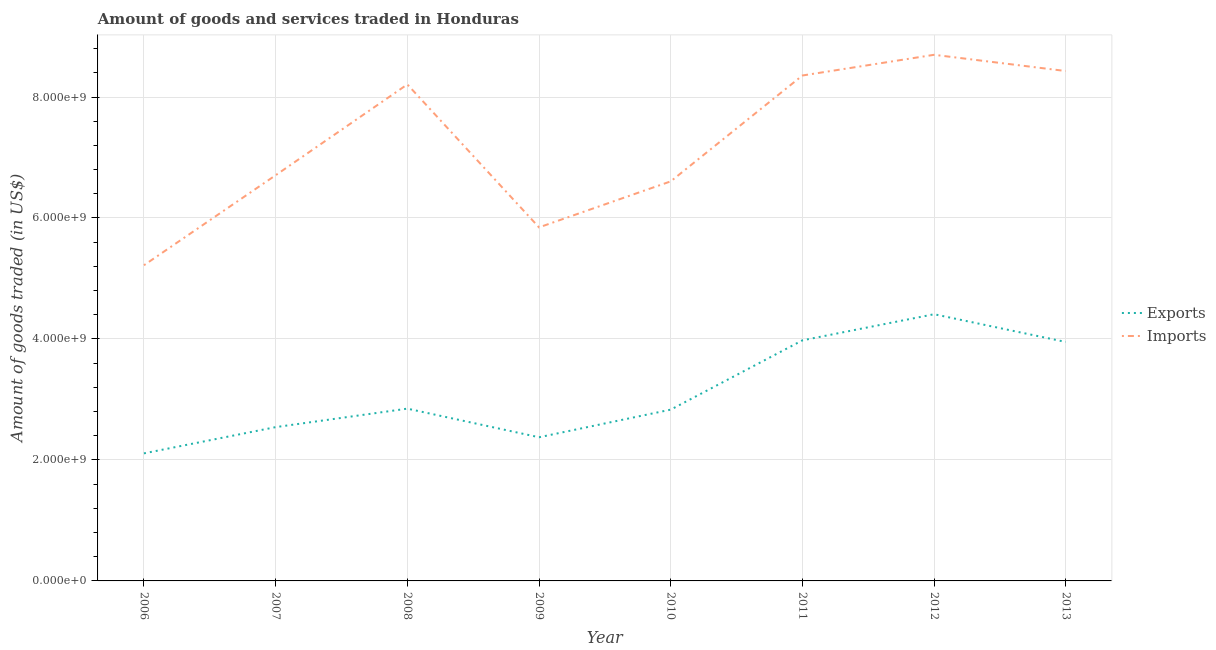Does the line corresponding to amount of goods exported intersect with the line corresponding to amount of goods imported?
Ensure brevity in your answer.  No. What is the amount of goods imported in 2007?
Ensure brevity in your answer.  6.71e+09. Across all years, what is the maximum amount of goods exported?
Your answer should be compact. 4.41e+09. Across all years, what is the minimum amount of goods imported?
Offer a very short reply. 5.22e+09. What is the total amount of goods imported in the graph?
Provide a short and direct response. 5.81e+1. What is the difference between the amount of goods exported in 2006 and that in 2007?
Your answer should be very brief. -4.34e+08. What is the difference between the amount of goods imported in 2011 and the amount of goods exported in 2008?
Offer a very short reply. 5.51e+09. What is the average amount of goods exported per year?
Your answer should be very brief. 3.13e+09. In the year 2008, what is the difference between the amount of goods imported and amount of goods exported?
Give a very brief answer. 5.36e+09. What is the ratio of the amount of goods imported in 2006 to that in 2012?
Provide a short and direct response. 0.6. Is the amount of goods exported in 2012 less than that in 2013?
Your response must be concise. No. Is the difference between the amount of goods imported in 2009 and 2010 greater than the difference between the amount of goods exported in 2009 and 2010?
Give a very brief answer. No. What is the difference between the highest and the second highest amount of goods imported?
Offer a very short reply. 2.68e+08. What is the difference between the highest and the lowest amount of goods exported?
Your answer should be compact. 2.30e+09. In how many years, is the amount of goods exported greater than the average amount of goods exported taken over all years?
Provide a short and direct response. 3. Is the sum of the amount of goods imported in 2008 and 2009 greater than the maximum amount of goods exported across all years?
Give a very brief answer. Yes. Is the amount of goods exported strictly greater than the amount of goods imported over the years?
Give a very brief answer. No. Is the amount of goods imported strictly less than the amount of goods exported over the years?
Your answer should be compact. No. How many lines are there?
Offer a terse response. 2. How many years are there in the graph?
Offer a terse response. 8. Does the graph contain grids?
Provide a succinct answer. Yes. How are the legend labels stacked?
Your response must be concise. Vertical. What is the title of the graph?
Offer a very short reply. Amount of goods and services traded in Honduras. Does "current US$" appear as one of the legend labels in the graph?
Make the answer very short. No. What is the label or title of the Y-axis?
Make the answer very short. Amount of goods traded (in US$). What is the Amount of goods traded (in US$) of Exports in 2006?
Ensure brevity in your answer.  2.11e+09. What is the Amount of goods traded (in US$) in Imports in 2006?
Provide a succinct answer. 5.22e+09. What is the Amount of goods traded (in US$) of Exports in 2007?
Keep it short and to the point. 2.54e+09. What is the Amount of goods traded (in US$) of Imports in 2007?
Your response must be concise. 6.71e+09. What is the Amount of goods traded (in US$) in Exports in 2008?
Offer a terse response. 2.85e+09. What is the Amount of goods traded (in US$) of Imports in 2008?
Provide a succinct answer. 8.21e+09. What is the Amount of goods traded (in US$) of Exports in 2009?
Ensure brevity in your answer.  2.38e+09. What is the Amount of goods traded (in US$) of Imports in 2009?
Your response must be concise. 5.85e+09. What is the Amount of goods traded (in US$) of Exports in 2010?
Your response must be concise. 2.83e+09. What is the Amount of goods traded (in US$) of Imports in 2010?
Make the answer very short. 6.61e+09. What is the Amount of goods traded (in US$) of Exports in 2011?
Your answer should be very brief. 3.98e+09. What is the Amount of goods traded (in US$) in Imports in 2011?
Your answer should be compact. 8.36e+09. What is the Amount of goods traded (in US$) in Exports in 2012?
Your answer should be very brief. 4.41e+09. What is the Amount of goods traded (in US$) of Imports in 2012?
Provide a short and direct response. 8.70e+09. What is the Amount of goods traded (in US$) of Exports in 2013?
Your answer should be compact. 3.95e+09. What is the Amount of goods traded (in US$) in Imports in 2013?
Provide a short and direct response. 8.43e+09. Across all years, what is the maximum Amount of goods traded (in US$) of Exports?
Your answer should be compact. 4.41e+09. Across all years, what is the maximum Amount of goods traded (in US$) of Imports?
Your response must be concise. 8.70e+09. Across all years, what is the minimum Amount of goods traded (in US$) of Exports?
Your response must be concise. 2.11e+09. Across all years, what is the minimum Amount of goods traded (in US$) of Imports?
Keep it short and to the point. 5.22e+09. What is the total Amount of goods traded (in US$) in Exports in the graph?
Provide a succinct answer. 2.50e+1. What is the total Amount of goods traded (in US$) in Imports in the graph?
Offer a terse response. 5.81e+1. What is the difference between the Amount of goods traded (in US$) of Exports in 2006 and that in 2007?
Your answer should be compact. -4.34e+08. What is the difference between the Amount of goods traded (in US$) in Imports in 2006 and that in 2007?
Keep it short and to the point. -1.49e+09. What is the difference between the Amount of goods traded (in US$) in Exports in 2006 and that in 2008?
Give a very brief answer. -7.39e+08. What is the difference between the Amount of goods traded (in US$) of Imports in 2006 and that in 2008?
Your answer should be compact. -2.99e+09. What is the difference between the Amount of goods traded (in US$) in Exports in 2006 and that in 2009?
Offer a very short reply. -2.66e+08. What is the difference between the Amount of goods traded (in US$) in Imports in 2006 and that in 2009?
Give a very brief answer. -6.26e+08. What is the difference between the Amount of goods traded (in US$) of Exports in 2006 and that in 2010?
Offer a very short reply. -7.23e+08. What is the difference between the Amount of goods traded (in US$) of Imports in 2006 and that in 2010?
Provide a short and direct response. -1.39e+09. What is the difference between the Amount of goods traded (in US$) of Exports in 2006 and that in 2011?
Keep it short and to the point. -1.87e+09. What is the difference between the Amount of goods traded (in US$) in Imports in 2006 and that in 2011?
Your response must be concise. -3.14e+09. What is the difference between the Amount of goods traded (in US$) of Exports in 2006 and that in 2012?
Provide a succinct answer. -2.30e+09. What is the difference between the Amount of goods traded (in US$) of Imports in 2006 and that in 2012?
Your answer should be very brief. -3.48e+09. What is the difference between the Amount of goods traded (in US$) in Exports in 2006 and that in 2013?
Your response must be concise. -1.84e+09. What is the difference between the Amount of goods traded (in US$) of Imports in 2006 and that in 2013?
Your response must be concise. -3.21e+09. What is the difference between the Amount of goods traded (in US$) in Exports in 2007 and that in 2008?
Offer a very short reply. -3.05e+08. What is the difference between the Amount of goods traded (in US$) of Imports in 2007 and that in 2008?
Your answer should be compact. -1.50e+09. What is the difference between the Amount of goods traded (in US$) of Exports in 2007 and that in 2009?
Keep it short and to the point. 1.68e+08. What is the difference between the Amount of goods traded (in US$) of Imports in 2007 and that in 2009?
Give a very brief answer. 8.62e+08. What is the difference between the Amount of goods traded (in US$) in Exports in 2007 and that in 2010?
Your answer should be very brief. -2.89e+08. What is the difference between the Amount of goods traded (in US$) in Imports in 2007 and that in 2010?
Your answer should be very brief. 1.01e+08. What is the difference between the Amount of goods traded (in US$) in Exports in 2007 and that in 2011?
Your answer should be very brief. -1.43e+09. What is the difference between the Amount of goods traded (in US$) in Imports in 2007 and that in 2011?
Your answer should be compact. -1.65e+09. What is the difference between the Amount of goods traded (in US$) in Exports in 2007 and that in 2012?
Offer a very short reply. -1.87e+09. What is the difference between the Amount of goods traded (in US$) of Imports in 2007 and that in 2012?
Provide a short and direct response. -1.99e+09. What is the difference between the Amount of goods traded (in US$) in Exports in 2007 and that in 2013?
Provide a short and direct response. -1.41e+09. What is the difference between the Amount of goods traded (in US$) of Imports in 2007 and that in 2013?
Provide a succinct answer. -1.72e+09. What is the difference between the Amount of goods traded (in US$) of Exports in 2008 and that in 2009?
Ensure brevity in your answer.  4.73e+08. What is the difference between the Amount of goods traded (in US$) in Imports in 2008 and that in 2009?
Make the answer very short. 2.36e+09. What is the difference between the Amount of goods traded (in US$) of Exports in 2008 and that in 2010?
Provide a short and direct response. 1.64e+07. What is the difference between the Amount of goods traded (in US$) in Imports in 2008 and that in 2010?
Ensure brevity in your answer.  1.60e+09. What is the difference between the Amount of goods traded (in US$) in Exports in 2008 and that in 2011?
Offer a very short reply. -1.13e+09. What is the difference between the Amount of goods traded (in US$) in Imports in 2008 and that in 2011?
Give a very brief answer. -1.47e+08. What is the difference between the Amount of goods traded (in US$) of Exports in 2008 and that in 2012?
Provide a short and direct response. -1.56e+09. What is the difference between the Amount of goods traded (in US$) of Imports in 2008 and that in 2012?
Give a very brief answer. -4.89e+08. What is the difference between the Amount of goods traded (in US$) in Exports in 2008 and that in 2013?
Provide a short and direct response. -1.10e+09. What is the difference between the Amount of goods traded (in US$) of Imports in 2008 and that in 2013?
Provide a short and direct response. -2.21e+08. What is the difference between the Amount of goods traded (in US$) of Exports in 2009 and that in 2010?
Your response must be concise. -4.57e+08. What is the difference between the Amount of goods traded (in US$) of Imports in 2009 and that in 2010?
Ensure brevity in your answer.  -7.61e+08. What is the difference between the Amount of goods traded (in US$) in Exports in 2009 and that in 2011?
Offer a very short reply. -1.60e+09. What is the difference between the Amount of goods traded (in US$) of Imports in 2009 and that in 2011?
Offer a terse response. -2.51e+09. What is the difference between the Amount of goods traded (in US$) of Exports in 2009 and that in 2012?
Make the answer very short. -2.03e+09. What is the difference between the Amount of goods traded (in US$) of Imports in 2009 and that in 2012?
Keep it short and to the point. -2.85e+09. What is the difference between the Amount of goods traded (in US$) of Exports in 2009 and that in 2013?
Your answer should be very brief. -1.58e+09. What is the difference between the Amount of goods traded (in US$) in Imports in 2009 and that in 2013?
Provide a short and direct response. -2.58e+09. What is the difference between the Amount of goods traded (in US$) of Exports in 2010 and that in 2011?
Provide a succinct answer. -1.15e+09. What is the difference between the Amount of goods traded (in US$) of Imports in 2010 and that in 2011?
Keep it short and to the point. -1.75e+09. What is the difference between the Amount of goods traded (in US$) in Exports in 2010 and that in 2012?
Provide a succinct answer. -1.58e+09. What is the difference between the Amount of goods traded (in US$) in Imports in 2010 and that in 2012?
Give a very brief answer. -2.09e+09. What is the difference between the Amount of goods traded (in US$) of Exports in 2010 and that in 2013?
Offer a very short reply. -1.12e+09. What is the difference between the Amount of goods traded (in US$) in Imports in 2010 and that in 2013?
Provide a succinct answer. -1.82e+09. What is the difference between the Amount of goods traded (in US$) in Exports in 2011 and that in 2012?
Ensure brevity in your answer.  -4.32e+08. What is the difference between the Amount of goods traded (in US$) of Imports in 2011 and that in 2012?
Your response must be concise. -3.42e+08. What is the difference between the Amount of goods traded (in US$) of Exports in 2011 and that in 2013?
Offer a very short reply. 2.73e+07. What is the difference between the Amount of goods traded (in US$) in Imports in 2011 and that in 2013?
Offer a terse response. -7.37e+07. What is the difference between the Amount of goods traded (in US$) in Exports in 2012 and that in 2013?
Keep it short and to the point. 4.59e+08. What is the difference between the Amount of goods traded (in US$) of Imports in 2012 and that in 2013?
Make the answer very short. 2.68e+08. What is the difference between the Amount of goods traded (in US$) of Exports in 2006 and the Amount of goods traded (in US$) of Imports in 2007?
Offer a very short reply. -4.60e+09. What is the difference between the Amount of goods traded (in US$) in Exports in 2006 and the Amount of goods traded (in US$) in Imports in 2008?
Keep it short and to the point. -6.10e+09. What is the difference between the Amount of goods traded (in US$) in Exports in 2006 and the Amount of goods traded (in US$) in Imports in 2009?
Give a very brief answer. -3.74e+09. What is the difference between the Amount of goods traded (in US$) in Exports in 2006 and the Amount of goods traded (in US$) in Imports in 2010?
Provide a short and direct response. -4.50e+09. What is the difference between the Amount of goods traded (in US$) of Exports in 2006 and the Amount of goods traded (in US$) of Imports in 2011?
Your answer should be very brief. -6.25e+09. What is the difference between the Amount of goods traded (in US$) of Exports in 2006 and the Amount of goods traded (in US$) of Imports in 2012?
Your answer should be very brief. -6.59e+09. What is the difference between the Amount of goods traded (in US$) in Exports in 2006 and the Amount of goods traded (in US$) in Imports in 2013?
Your answer should be compact. -6.32e+09. What is the difference between the Amount of goods traded (in US$) of Exports in 2007 and the Amount of goods traded (in US$) of Imports in 2008?
Your answer should be very brief. -5.67e+09. What is the difference between the Amount of goods traded (in US$) in Exports in 2007 and the Amount of goods traded (in US$) in Imports in 2009?
Provide a succinct answer. -3.30e+09. What is the difference between the Amount of goods traded (in US$) of Exports in 2007 and the Amount of goods traded (in US$) of Imports in 2010?
Offer a terse response. -4.06e+09. What is the difference between the Amount of goods traded (in US$) in Exports in 2007 and the Amount of goods traded (in US$) in Imports in 2011?
Your answer should be compact. -5.81e+09. What is the difference between the Amount of goods traded (in US$) of Exports in 2007 and the Amount of goods traded (in US$) of Imports in 2012?
Your answer should be compact. -6.16e+09. What is the difference between the Amount of goods traded (in US$) of Exports in 2007 and the Amount of goods traded (in US$) of Imports in 2013?
Ensure brevity in your answer.  -5.89e+09. What is the difference between the Amount of goods traded (in US$) of Exports in 2008 and the Amount of goods traded (in US$) of Imports in 2009?
Offer a very short reply. -3.00e+09. What is the difference between the Amount of goods traded (in US$) in Exports in 2008 and the Amount of goods traded (in US$) in Imports in 2010?
Offer a terse response. -3.76e+09. What is the difference between the Amount of goods traded (in US$) of Exports in 2008 and the Amount of goods traded (in US$) of Imports in 2011?
Your answer should be compact. -5.51e+09. What is the difference between the Amount of goods traded (in US$) of Exports in 2008 and the Amount of goods traded (in US$) of Imports in 2012?
Make the answer very short. -5.85e+09. What is the difference between the Amount of goods traded (in US$) of Exports in 2008 and the Amount of goods traded (in US$) of Imports in 2013?
Give a very brief answer. -5.58e+09. What is the difference between the Amount of goods traded (in US$) of Exports in 2009 and the Amount of goods traded (in US$) of Imports in 2010?
Keep it short and to the point. -4.23e+09. What is the difference between the Amount of goods traded (in US$) of Exports in 2009 and the Amount of goods traded (in US$) of Imports in 2011?
Offer a terse response. -5.98e+09. What is the difference between the Amount of goods traded (in US$) in Exports in 2009 and the Amount of goods traded (in US$) in Imports in 2012?
Provide a short and direct response. -6.32e+09. What is the difference between the Amount of goods traded (in US$) of Exports in 2009 and the Amount of goods traded (in US$) of Imports in 2013?
Provide a short and direct response. -6.05e+09. What is the difference between the Amount of goods traded (in US$) of Exports in 2010 and the Amount of goods traded (in US$) of Imports in 2011?
Your response must be concise. -5.52e+09. What is the difference between the Amount of goods traded (in US$) of Exports in 2010 and the Amount of goods traded (in US$) of Imports in 2012?
Ensure brevity in your answer.  -5.87e+09. What is the difference between the Amount of goods traded (in US$) of Exports in 2010 and the Amount of goods traded (in US$) of Imports in 2013?
Your answer should be compact. -5.60e+09. What is the difference between the Amount of goods traded (in US$) in Exports in 2011 and the Amount of goods traded (in US$) in Imports in 2012?
Give a very brief answer. -4.72e+09. What is the difference between the Amount of goods traded (in US$) of Exports in 2011 and the Amount of goods traded (in US$) of Imports in 2013?
Offer a very short reply. -4.45e+09. What is the difference between the Amount of goods traded (in US$) in Exports in 2012 and the Amount of goods traded (in US$) in Imports in 2013?
Offer a terse response. -4.02e+09. What is the average Amount of goods traded (in US$) of Exports per year?
Your response must be concise. 3.13e+09. What is the average Amount of goods traded (in US$) in Imports per year?
Your answer should be very brief. 7.26e+09. In the year 2006, what is the difference between the Amount of goods traded (in US$) of Exports and Amount of goods traded (in US$) of Imports?
Give a very brief answer. -3.11e+09. In the year 2007, what is the difference between the Amount of goods traded (in US$) of Exports and Amount of goods traded (in US$) of Imports?
Provide a short and direct response. -4.16e+09. In the year 2008, what is the difference between the Amount of goods traded (in US$) of Exports and Amount of goods traded (in US$) of Imports?
Offer a terse response. -5.36e+09. In the year 2009, what is the difference between the Amount of goods traded (in US$) in Exports and Amount of goods traded (in US$) in Imports?
Give a very brief answer. -3.47e+09. In the year 2010, what is the difference between the Amount of goods traded (in US$) in Exports and Amount of goods traded (in US$) in Imports?
Offer a terse response. -3.77e+09. In the year 2011, what is the difference between the Amount of goods traded (in US$) in Exports and Amount of goods traded (in US$) in Imports?
Offer a very short reply. -4.38e+09. In the year 2012, what is the difference between the Amount of goods traded (in US$) in Exports and Amount of goods traded (in US$) in Imports?
Offer a terse response. -4.29e+09. In the year 2013, what is the difference between the Amount of goods traded (in US$) in Exports and Amount of goods traded (in US$) in Imports?
Give a very brief answer. -4.48e+09. What is the ratio of the Amount of goods traded (in US$) in Exports in 2006 to that in 2007?
Your answer should be compact. 0.83. What is the ratio of the Amount of goods traded (in US$) in Imports in 2006 to that in 2007?
Provide a succinct answer. 0.78. What is the ratio of the Amount of goods traded (in US$) in Exports in 2006 to that in 2008?
Give a very brief answer. 0.74. What is the ratio of the Amount of goods traded (in US$) of Imports in 2006 to that in 2008?
Your answer should be compact. 0.64. What is the ratio of the Amount of goods traded (in US$) of Exports in 2006 to that in 2009?
Provide a succinct answer. 0.89. What is the ratio of the Amount of goods traded (in US$) in Imports in 2006 to that in 2009?
Your response must be concise. 0.89. What is the ratio of the Amount of goods traded (in US$) in Exports in 2006 to that in 2010?
Provide a succinct answer. 0.74. What is the ratio of the Amount of goods traded (in US$) of Imports in 2006 to that in 2010?
Offer a terse response. 0.79. What is the ratio of the Amount of goods traded (in US$) of Exports in 2006 to that in 2011?
Provide a succinct answer. 0.53. What is the ratio of the Amount of goods traded (in US$) of Imports in 2006 to that in 2011?
Offer a terse response. 0.62. What is the ratio of the Amount of goods traded (in US$) of Exports in 2006 to that in 2012?
Provide a short and direct response. 0.48. What is the ratio of the Amount of goods traded (in US$) of Imports in 2006 to that in 2012?
Keep it short and to the point. 0.6. What is the ratio of the Amount of goods traded (in US$) of Exports in 2006 to that in 2013?
Your answer should be very brief. 0.53. What is the ratio of the Amount of goods traded (in US$) of Imports in 2006 to that in 2013?
Offer a very short reply. 0.62. What is the ratio of the Amount of goods traded (in US$) of Exports in 2007 to that in 2008?
Your answer should be compact. 0.89. What is the ratio of the Amount of goods traded (in US$) of Imports in 2007 to that in 2008?
Offer a terse response. 0.82. What is the ratio of the Amount of goods traded (in US$) of Exports in 2007 to that in 2009?
Your answer should be compact. 1.07. What is the ratio of the Amount of goods traded (in US$) of Imports in 2007 to that in 2009?
Your answer should be compact. 1.15. What is the ratio of the Amount of goods traded (in US$) in Exports in 2007 to that in 2010?
Give a very brief answer. 0.9. What is the ratio of the Amount of goods traded (in US$) in Imports in 2007 to that in 2010?
Keep it short and to the point. 1.02. What is the ratio of the Amount of goods traded (in US$) in Exports in 2007 to that in 2011?
Offer a terse response. 0.64. What is the ratio of the Amount of goods traded (in US$) in Imports in 2007 to that in 2011?
Ensure brevity in your answer.  0.8. What is the ratio of the Amount of goods traded (in US$) of Exports in 2007 to that in 2012?
Provide a succinct answer. 0.58. What is the ratio of the Amount of goods traded (in US$) of Imports in 2007 to that in 2012?
Provide a short and direct response. 0.77. What is the ratio of the Amount of goods traded (in US$) in Exports in 2007 to that in 2013?
Keep it short and to the point. 0.64. What is the ratio of the Amount of goods traded (in US$) in Imports in 2007 to that in 2013?
Keep it short and to the point. 0.8. What is the ratio of the Amount of goods traded (in US$) in Exports in 2008 to that in 2009?
Offer a terse response. 1.2. What is the ratio of the Amount of goods traded (in US$) in Imports in 2008 to that in 2009?
Ensure brevity in your answer.  1.4. What is the ratio of the Amount of goods traded (in US$) of Imports in 2008 to that in 2010?
Provide a succinct answer. 1.24. What is the ratio of the Amount of goods traded (in US$) in Exports in 2008 to that in 2011?
Offer a very short reply. 0.72. What is the ratio of the Amount of goods traded (in US$) in Imports in 2008 to that in 2011?
Your answer should be very brief. 0.98. What is the ratio of the Amount of goods traded (in US$) in Exports in 2008 to that in 2012?
Keep it short and to the point. 0.65. What is the ratio of the Amount of goods traded (in US$) of Imports in 2008 to that in 2012?
Provide a succinct answer. 0.94. What is the ratio of the Amount of goods traded (in US$) in Exports in 2008 to that in 2013?
Ensure brevity in your answer.  0.72. What is the ratio of the Amount of goods traded (in US$) of Imports in 2008 to that in 2013?
Offer a terse response. 0.97. What is the ratio of the Amount of goods traded (in US$) of Exports in 2009 to that in 2010?
Your answer should be very brief. 0.84. What is the ratio of the Amount of goods traded (in US$) in Imports in 2009 to that in 2010?
Provide a short and direct response. 0.88. What is the ratio of the Amount of goods traded (in US$) in Exports in 2009 to that in 2011?
Offer a terse response. 0.6. What is the ratio of the Amount of goods traded (in US$) of Imports in 2009 to that in 2011?
Keep it short and to the point. 0.7. What is the ratio of the Amount of goods traded (in US$) in Exports in 2009 to that in 2012?
Provide a succinct answer. 0.54. What is the ratio of the Amount of goods traded (in US$) in Imports in 2009 to that in 2012?
Give a very brief answer. 0.67. What is the ratio of the Amount of goods traded (in US$) in Exports in 2009 to that in 2013?
Offer a very short reply. 0.6. What is the ratio of the Amount of goods traded (in US$) in Imports in 2009 to that in 2013?
Provide a succinct answer. 0.69. What is the ratio of the Amount of goods traded (in US$) in Exports in 2010 to that in 2011?
Offer a terse response. 0.71. What is the ratio of the Amount of goods traded (in US$) of Imports in 2010 to that in 2011?
Provide a short and direct response. 0.79. What is the ratio of the Amount of goods traded (in US$) in Exports in 2010 to that in 2012?
Provide a succinct answer. 0.64. What is the ratio of the Amount of goods traded (in US$) of Imports in 2010 to that in 2012?
Keep it short and to the point. 0.76. What is the ratio of the Amount of goods traded (in US$) of Exports in 2010 to that in 2013?
Keep it short and to the point. 0.72. What is the ratio of the Amount of goods traded (in US$) in Imports in 2010 to that in 2013?
Your answer should be compact. 0.78. What is the ratio of the Amount of goods traded (in US$) in Exports in 2011 to that in 2012?
Give a very brief answer. 0.9. What is the ratio of the Amount of goods traded (in US$) in Imports in 2011 to that in 2012?
Your answer should be very brief. 0.96. What is the ratio of the Amount of goods traded (in US$) in Exports in 2012 to that in 2013?
Your answer should be very brief. 1.12. What is the ratio of the Amount of goods traded (in US$) of Imports in 2012 to that in 2013?
Provide a succinct answer. 1.03. What is the difference between the highest and the second highest Amount of goods traded (in US$) in Exports?
Give a very brief answer. 4.32e+08. What is the difference between the highest and the second highest Amount of goods traded (in US$) in Imports?
Provide a succinct answer. 2.68e+08. What is the difference between the highest and the lowest Amount of goods traded (in US$) of Exports?
Offer a very short reply. 2.30e+09. What is the difference between the highest and the lowest Amount of goods traded (in US$) of Imports?
Give a very brief answer. 3.48e+09. 